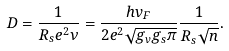<formula> <loc_0><loc_0><loc_500><loc_500>D = \frac { 1 } { R _ { s } e ^ { 2 } \nu } = \frac { h v _ { F } } { 2 e ^ { 2 } \sqrt { g _ { v } g _ { s } \pi } } \frac { 1 } { R _ { s } \sqrt { n } } .</formula> 